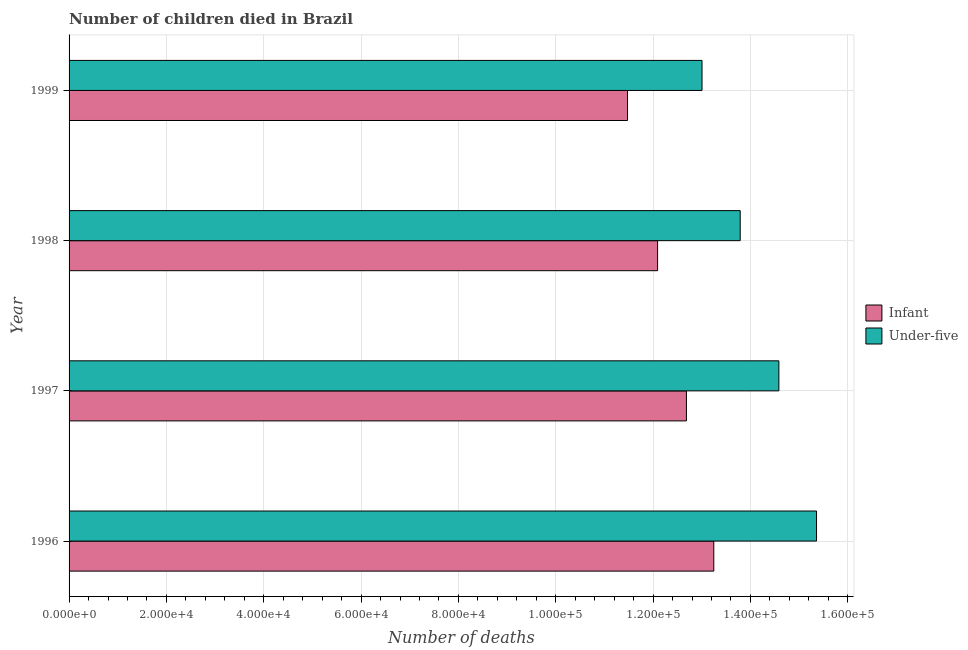How many different coloured bars are there?
Make the answer very short. 2. How many groups of bars are there?
Offer a terse response. 4. Are the number of bars per tick equal to the number of legend labels?
Offer a terse response. Yes. Are the number of bars on each tick of the Y-axis equal?
Keep it short and to the point. Yes. How many bars are there on the 1st tick from the top?
Keep it short and to the point. 2. What is the label of the 3rd group of bars from the top?
Give a very brief answer. 1997. In how many cases, is the number of bars for a given year not equal to the number of legend labels?
Offer a very short reply. 0. What is the number of under-five deaths in 1998?
Provide a short and direct response. 1.38e+05. Across all years, what is the maximum number of under-five deaths?
Make the answer very short. 1.54e+05. Across all years, what is the minimum number of infant deaths?
Ensure brevity in your answer.  1.15e+05. In which year was the number of infant deaths maximum?
Keep it short and to the point. 1996. In which year was the number of under-five deaths minimum?
Your answer should be compact. 1999. What is the total number of infant deaths in the graph?
Provide a succinct answer. 4.95e+05. What is the difference between the number of under-five deaths in 1997 and that in 1999?
Keep it short and to the point. 1.58e+04. What is the difference between the number of infant deaths in 1999 and the number of under-five deaths in 1997?
Make the answer very short. -3.11e+04. What is the average number of infant deaths per year?
Offer a very short reply. 1.24e+05. In the year 1996, what is the difference between the number of under-five deaths and number of infant deaths?
Keep it short and to the point. 2.11e+04. In how many years, is the number of under-five deaths greater than 136000 ?
Offer a very short reply. 3. What is the ratio of the number of under-five deaths in 1997 to that in 1998?
Your answer should be compact. 1.06. Is the number of under-five deaths in 1998 less than that in 1999?
Your answer should be compact. No. What is the difference between the highest and the second highest number of under-five deaths?
Give a very brief answer. 7735. What is the difference between the highest and the lowest number of under-five deaths?
Provide a short and direct response. 2.35e+04. In how many years, is the number of under-five deaths greater than the average number of under-five deaths taken over all years?
Make the answer very short. 2. What does the 1st bar from the top in 1998 represents?
Your response must be concise. Under-five. What does the 1st bar from the bottom in 1999 represents?
Make the answer very short. Infant. Does the graph contain any zero values?
Your answer should be very brief. No. Where does the legend appear in the graph?
Give a very brief answer. Center right. How are the legend labels stacked?
Ensure brevity in your answer.  Vertical. What is the title of the graph?
Make the answer very short. Number of children died in Brazil. Does "Domestic liabilities" appear as one of the legend labels in the graph?
Provide a short and direct response. No. What is the label or title of the X-axis?
Keep it short and to the point. Number of deaths. What is the Number of deaths of Infant in 1996?
Your answer should be compact. 1.32e+05. What is the Number of deaths of Under-five in 1996?
Offer a terse response. 1.54e+05. What is the Number of deaths of Infant in 1997?
Provide a succinct answer. 1.27e+05. What is the Number of deaths of Under-five in 1997?
Your answer should be very brief. 1.46e+05. What is the Number of deaths in Infant in 1998?
Keep it short and to the point. 1.21e+05. What is the Number of deaths in Under-five in 1998?
Your answer should be very brief. 1.38e+05. What is the Number of deaths of Infant in 1999?
Your answer should be very brief. 1.15e+05. What is the Number of deaths of Under-five in 1999?
Make the answer very short. 1.30e+05. Across all years, what is the maximum Number of deaths of Infant?
Offer a terse response. 1.32e+05. Across all years, what is the maximum Number of deaths in Under-five?
Give a very brief answer. 1.54e+05. Across all years, what is the minimum Number of deaths in Infant?
Give a very brief answer. 1.15e+05. Across all years, what is the minimum Number of deaths in Under-five?
Your response must be concise. 1.30e+05. What is the total Number of deaths of Infant in the graph?
Your answer should be compact. 4.95e+05. What is the total Number of deaths of Under-five in the graph?
Keep it short and to the point. 5.67e+05. What is the difference between the Number of deaths in Infant in 1996 and that in 1997?
Give a very brief answer. 5624. What is the difference between the Number of deaths in Under-five in 1996 and that in 1997?
Give a very brief answer. 7735. What is the difference between the Number of deaths in Infant in 1996 and that in 1998?
Your response must be concise. 1.15e+04. What is the difference between the Number of deaths in Under-five in 1996 and that in 1998?
Offer a terse response. 1.57e+04. What is the difference between the Number of deaths in Infant in 1996 and that in 1999?
Offer a very short reply. 1.77e+04. What is the difference between the Number of deaths of Under-five in 1996 and that in 1999?
Your answer should be compact. 2.35e+04. What is the difference between the Number of deaths of Infant in 1997 and that in 1998?
Provide a succinct answer. 5922. What is the difference between the Number of deaths in Under-five in 1997 and that in 1998?
Give a very brief answer. 7946. What is the difference between the Number of deaths in Infant in 1997 and that in 1999?
Provide a succinct answer. 1.21e+04. What is the difference between the Number of deaths of Under-five in 1997 and that in 1999?
Your answer should be compact. 1.58e+04. What is the difference between the Number of deaths in Infant in 1998 and that in 1999?
Provide a succinct answer. 6182. What is the difference between the Number of deaths in Under-five in 1998 and that in 1999?
Your answer should be compact. 7847. What is the difference between the Number of deaths in Infant in 1996 and the Number of deaths in Under-five in 1997?
Keep it short and to the point. -1.34e+04. What is the difference between the Number of deaths in Infant in 1996 and the Number of deaths in Under-five in 1998?
Provide a short and direct response. -5428. What is the difference between the Number of deaths of Infant in 1996 and the Number of deaths of Under-five in 1999?
Your answer should be compact. 2419. What is the difference between the Number of deaths in Infant in 1997 and the Number of deaths in Under-five in 1998?
Offer a terse response. -1.11e+04. What is the difference between the Number of deaths in Infant in 1997 and the Number of deaths in Under-five in 1999?
Keep it short and to the point. -3205. What is the difference between the Number of deaths in Infant in 1998 and the Number of deaths in Under-five in 1999?
Offer a terse response. -9127. What is the average Number of deaths of Infant per year?
Your answer should be compact. 1.24e+05. What is the average Number of deaths of Under-five per year?
Make the answer very short. 1.42e+05. In the year 1996, what is the difference between the Number of deaths in Infant and Number of deaths in Under-five?
Make the answer very short. -2.11e+04. In the year 1997, what is the difference between the Number of deaths in Infant and Number of deaths in Under-five?
Offer a terse response. -1.90e+04. In the year 1998, what is the difference between the Number of deaths of Infant and Number of deaths of Under-five?
Provide a short and direct response. -1.70e+04. In the year 1999, what is the difference between the Number of deaths of Infant and Number of deaths of Under-five?
Your answer should be very brief. -1.53e+04. What is the ratio of the Number of deaths of Infant in 1996 to that in 1997?
Your answer should be compact. 1.04. What is the ratio of the Number of deaths of Under-five in 1996 to that in 1997?
Offer a very short reply. 1.05. What is the ratio of the Number of deaths of Infant in 1996 to that in 1998?
Your response must be concise. 1.1. What is the ratio of the Number of deaths in Under-five in 1996 to that in 1998?
Provide a succinct answer. 1.11. What is the ratio of the Number of deaths in Infant in 1996 to that in 1999?
Your answer should be compact. 1.15. What is the ratio of the Number of deaths of Under-five in 1996 to that in 1999?
Your answer should be very brief. 1.18. What is the ratio of the Number of deaths in Infant in 1997 to that in 1998?
Keep it short and to the point. 1.05. What is the ratio of the Number of deaths of Under-five in 1997 to that in 1998?
Offer a very short reply. 1.06. What is the ratio of the Number of deaths in Infant in 1997 to that in 1999?
Offer a terse response. 1.11. What is the ratio of the Number of deaths of Under-five in 1997 to that in 1999?
Provide a succinct answer. 1.12. What is the ratio of the Number of deaths of Infant in 1998 to that in 1999?
Provide a succinct answer. 1.05. What is the ratio of the Number of deaths in Under-five in 1998 to that in 1999?
Provide a succinct answer. 1.06. What is the difference between the highest and the second highest Number of deaths of Infant?
Your answer should be very brief. 5624. What is the difference between the highest and the second highest Number of deaths of Under-five?
Your response must be concise. 7735. What is the difference between the highest and the lowest Number of deaths of Infant?
Provide a short and direct response. 1.77e+04. What is the difference between the highest and the lowest Number of deaths in Under-five?
Your response must be concise. 2.35e+04. 